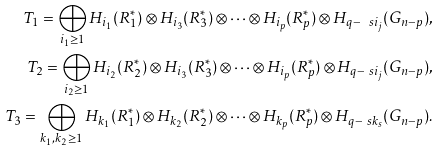<formula> <loc_0><loc_0><loc_500><loc_500>T _ { 1 } = \bigoplus _ { i _ { 1 } \geq 1 } H _ { i _ { 1 } } ( R _ { 1 } ^ { \ast } ) \otimes H _ { i _ { 3 } } ( R _ { 3 } ^ { \ast } ) \otimes \cdots \otimes H _ { i _ { p } } ( R _ { p } ^ { \ast } ) \otimes H _ { q - \ s i _ { j } } ( G _ { n - p } ) , \\ T _ { 2 } = \bigoplus _ { i _ { 2 } \geq 1 } H _ { i _ { 2 } } ( R _ { 2 } ^ { \ast } ) \otimes H _ { i _ { 3 } } ( R _ { 3 } ^ { \ast } ) \otimes \cdots \otimes H _ { i _ { p } } ( R _ { p } ^ { \ast } ) \otimes H _ { q - \ s i _ { j } } ( G _ { n - p } ) , \\ \quad \ T _ { 3 } = \bigoplus _ { k _ { 1 } , k _ { 2 } \geq 1 } H _ { k _ { 1 } } ( R _ { 1 } ^ { \ast } ) \otimes H _ { k _ { 2 } } ( R _ { 2 } ^ { \ast } ) \otimes \cdots \otimes H _ { k _ { p } } ( R _ { p } ^ { \ast } ) \otimes H _ { q - \ s k _ { s } } ( G _ { n - p } ) .</formula> 